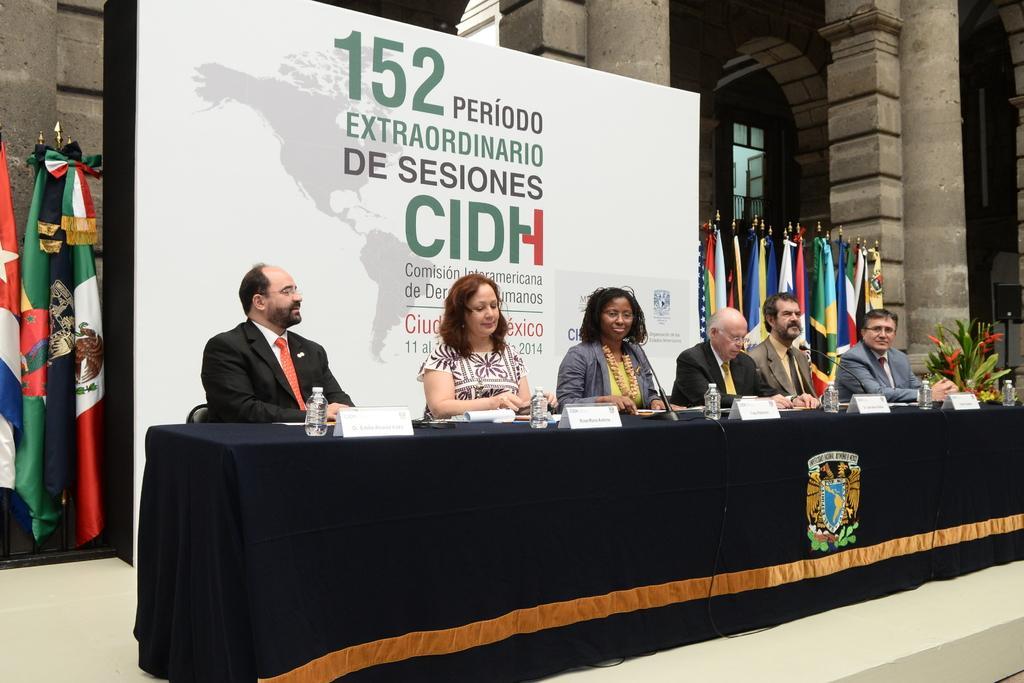In one or two sentences, can you explain what this image depicts? These people sitting and we can see microphones,bottles,name boards,papers and plant on the table. Background we can see flags,banner and pillars. 